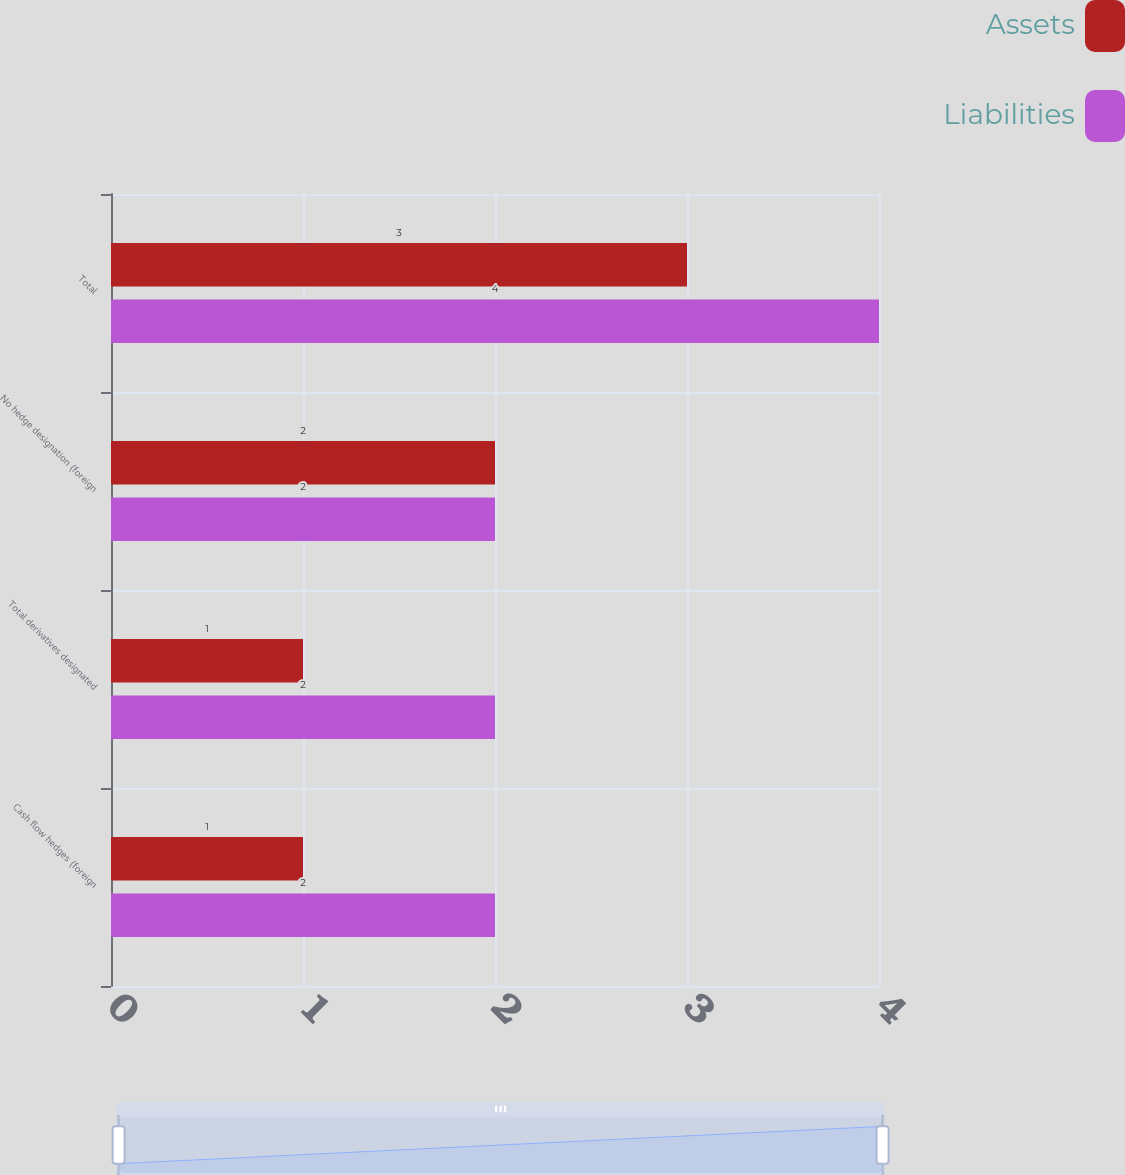Convert chart. <chart><loc_0><loc_0><loc_500><loc_500><stacked_bar_chart><ecel><fcel>Cash flow hedges (foreign<fcel>Total derivatives designated<fcel>No hedge designation (foreign<fcel>Total<nl><fcel>Assets<fcel>1<fcel>1<fcel>2<fcel>3<nl><fcel>Liabilities<fcel>2<fcel>2<fcel>2<fcel>4<nl></chart> 